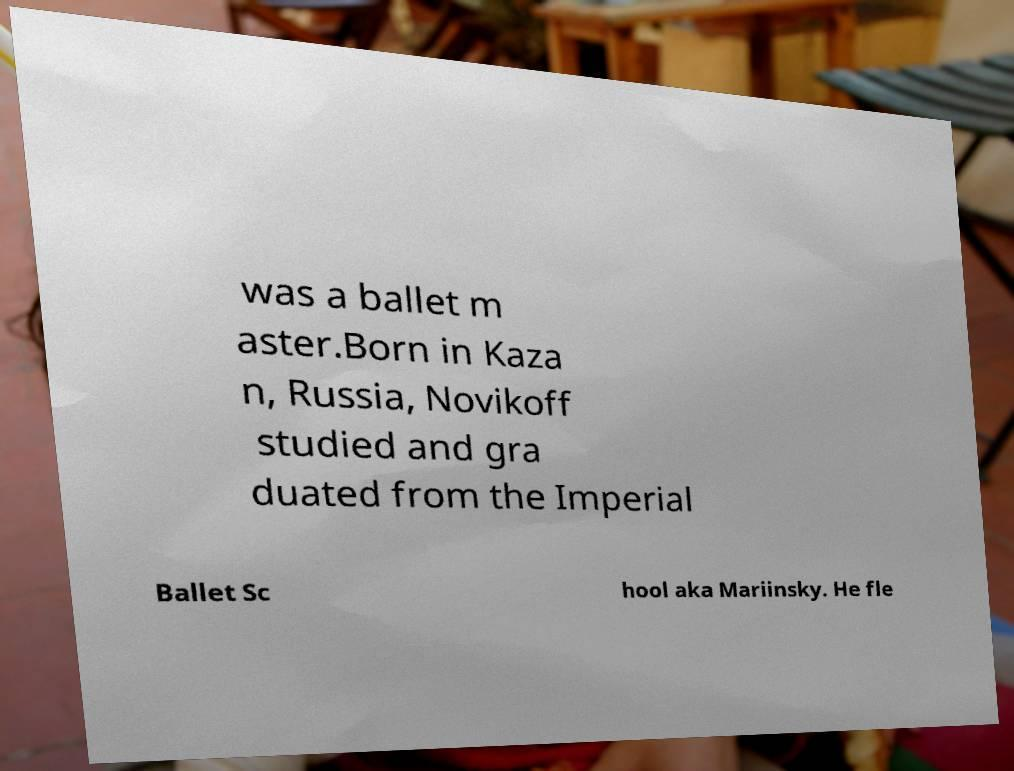Could you assist in decoding the text presented in this image and type it out clearly? was a ballet m aster.Born in Kaza n, Russia, Novikoff studied and gra duated from the Imperial Ballet Sc hool aka Mariinsky. He fle 